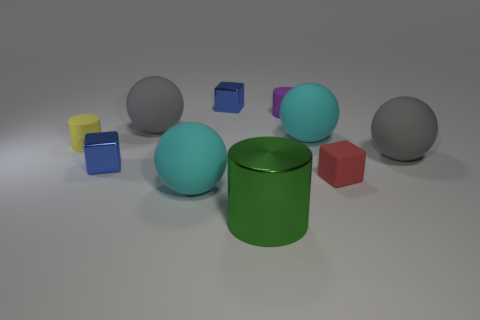Subtract all brown spheres. Subtract all red cylinders. How many spheres are left? 4 Subtract all spheres. How many objects are left? 6 Add 1 balls. How many balls exist? 5 Subtract 0 blue balls. How many objects are left? 10 Subtract all shiny cubes. Subtract all cubes. How many objects are left? 5 Add 2 gray matte spheres. How many gray matte spheres are left? 4 